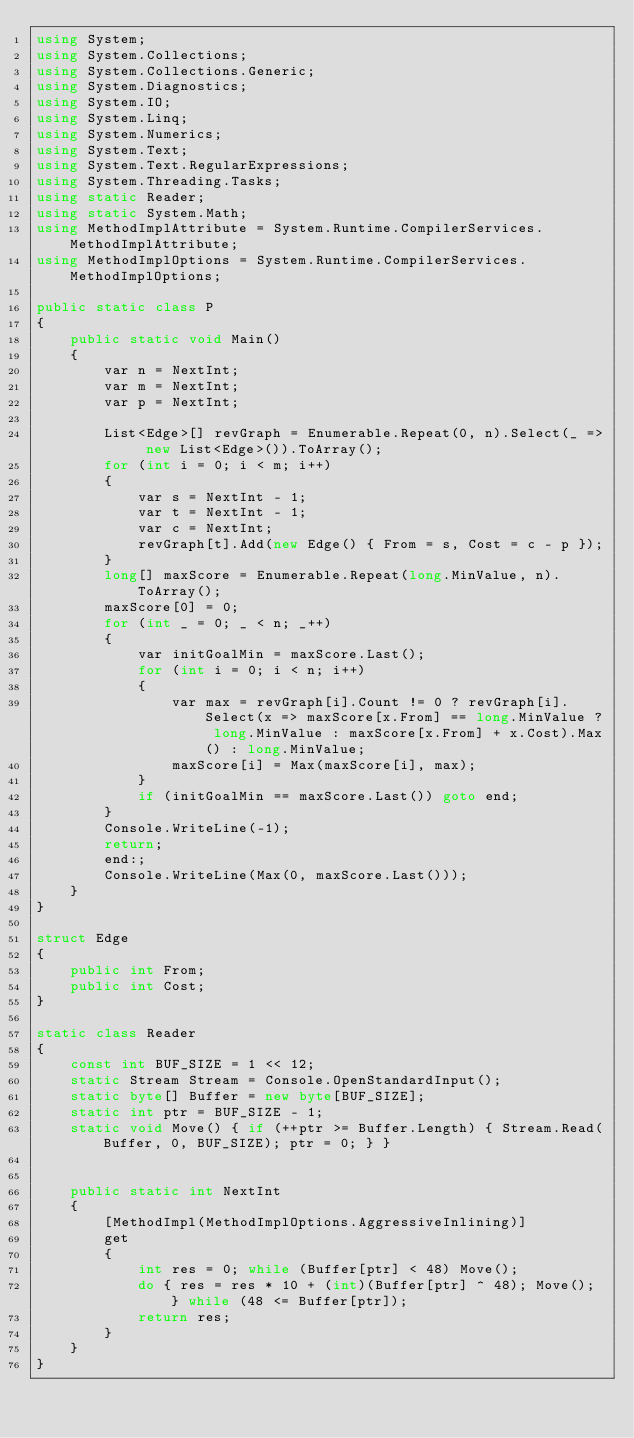<code> <loc_0><loc_0><loc_500><loc_500><_C#_>using System;
using System.Collections;
using System.Collections.Generic;
using System.Diagnostics;
using System.IO;
using System.Linq;
using System.Numerics;
using System.Text;
using System.Text.RegularExpressions;
using System.Threading.Tasks;
using static Reader;
using static System.Math;
using MethodImplAttribute = System.Runtime.CompilerServices.MethodImplAttribute;
using MethodImplOptions = System.Runtime.CompilerServices.MethodImplOptions;

public static class P
{
    public static void Main()
    {
        var n = NextInt;
        var m = NextInt;
        var p = NextInt;

        List<Edge>[] revGraph = Enumerable.Repeat(0, n).Select(_ => new List<Edge>()).ToArray();
        for (int i = 0; i < m; i++)
        {
            var s = NextInt - 1;
            var t = NextInt - 1;
            var c = NextInt;
            revGraph[t].Add(new Edge() { From = s, Cost = c - p });
        }
        long[] maxScore = Enumerable.Repeat(long.MinValue, n).ToArray();
        maxScore[0] = 0;
        for (int _ = 0; _ < n; _++)
        {
            var initGoalMin = maxScore.Last();
            for (int i = 0; i < n; i++)
            {
                var max = revGraph[i].Count != 0 ? revGraph[i].Select(x => maxScore[x.From] == long.MinValue ? long.MinValue : maxScore[x.From] + x.Cost).Max() : long.MinValue;
                maxScore[i] = Max(maxScore[i], max);
            }
            if (initGoalMin == maxScore.Last()) goto end;
        }
        Console.WriteLine(-1);
        return;
        end:;
        Console.WriteLine(Max(0, maxScore.Last()));
    }
}

struct Edge
{
    public int From;
    public int Cost;
}

static class Reader
{
    const int BUF_SIZE = 1 << 12;
    static Stream Stream = Console.OpenStandardInput();
    static byte[] Buffer = new byte[BUF_SIZE];
    static int ptr = BUF_SIZE - 1;
    static void Move() { if (++ptr >= Buffer.Length) { Stream.Read(Buffer, 0, BUF_SIZE); ptr = 0; } }


    public static int NextInt
    {
        [MethodImpl(MethodImplOptions.AggressiveInlining)]
        get
        {
            int res = 0; while (Buffer[ptr] < 48) Move();
            do { res = res * 10 + (int)(Buffer[ptr] ^ 48); Move(); } while (48 <= Buffer[ptr]);
            return res;
        }
    }
}
</code> 